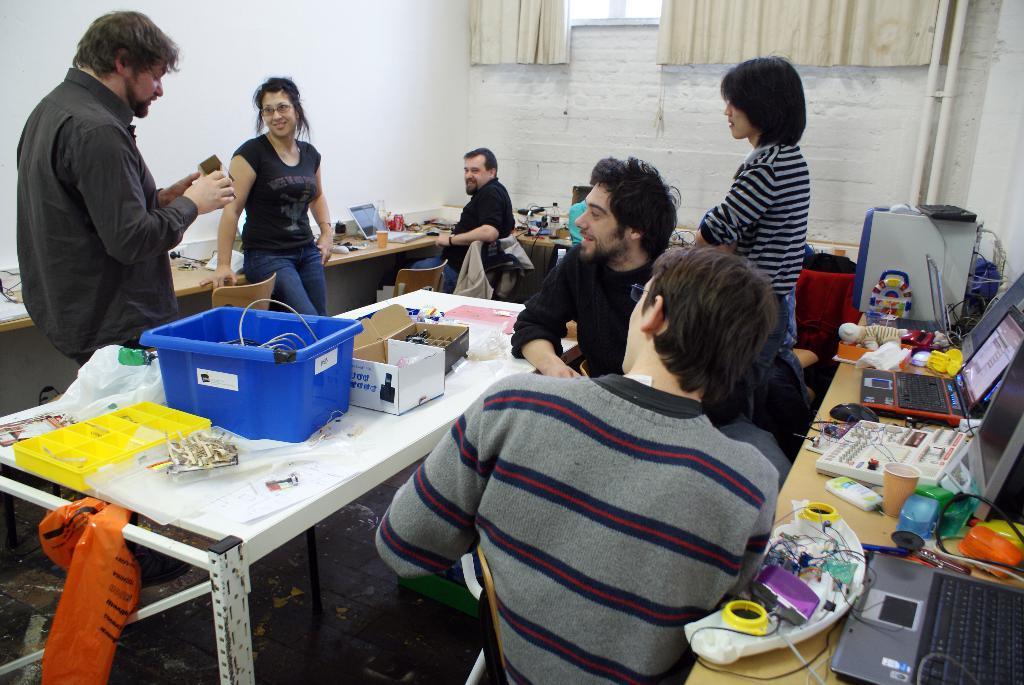In one or two sentences, can you explain what this image depicts? In this picture there are group of people those who are sitting around a table, there is a person who is standing at the left side of the image, he is explaining something and there is a table at the left side of the image which contains trays and different types of boxes on it and there are laptops all around the area of the table, there is a glass window at the center of the image. 